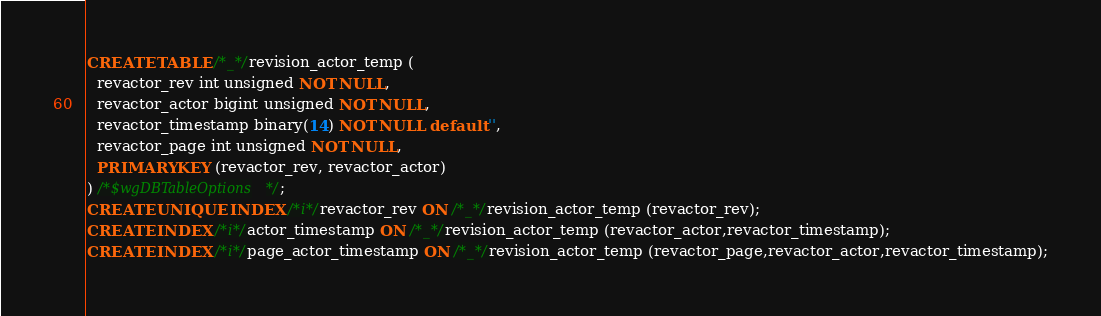<code> <loc_0><loc_0><loc_500><loc_500><_SQL_>CREATE TABLE /*_*/revision_actor_temp (
  revactor_rev int unsigned NOT NULL,
  revactor_actor bigint unsigned NOT NULL,
  revactor_timestamp binary(14) NOT NULL default '',
  revactor_page int unsigned NOT NULL,
  PRIMARY KEY (revactor_rev, revactor_actor)
) /*$wgDBTableOptions*/;
CREATE UNIQUE INDEX /*i*/revactor_rev ON /*_*/revision_actor_temp (revactor_rev);
CREATE INDEX /*i*/actor_timestamp ON /*_*/revision_actor_temp (revactor_actor,revactor_timestamp);
CREATE INDEX /*i*/page_actor_timestamp ON /*_*/revision_actor_temp (revactor_page,revactor_actor,revactor_timestamp);
</code> 